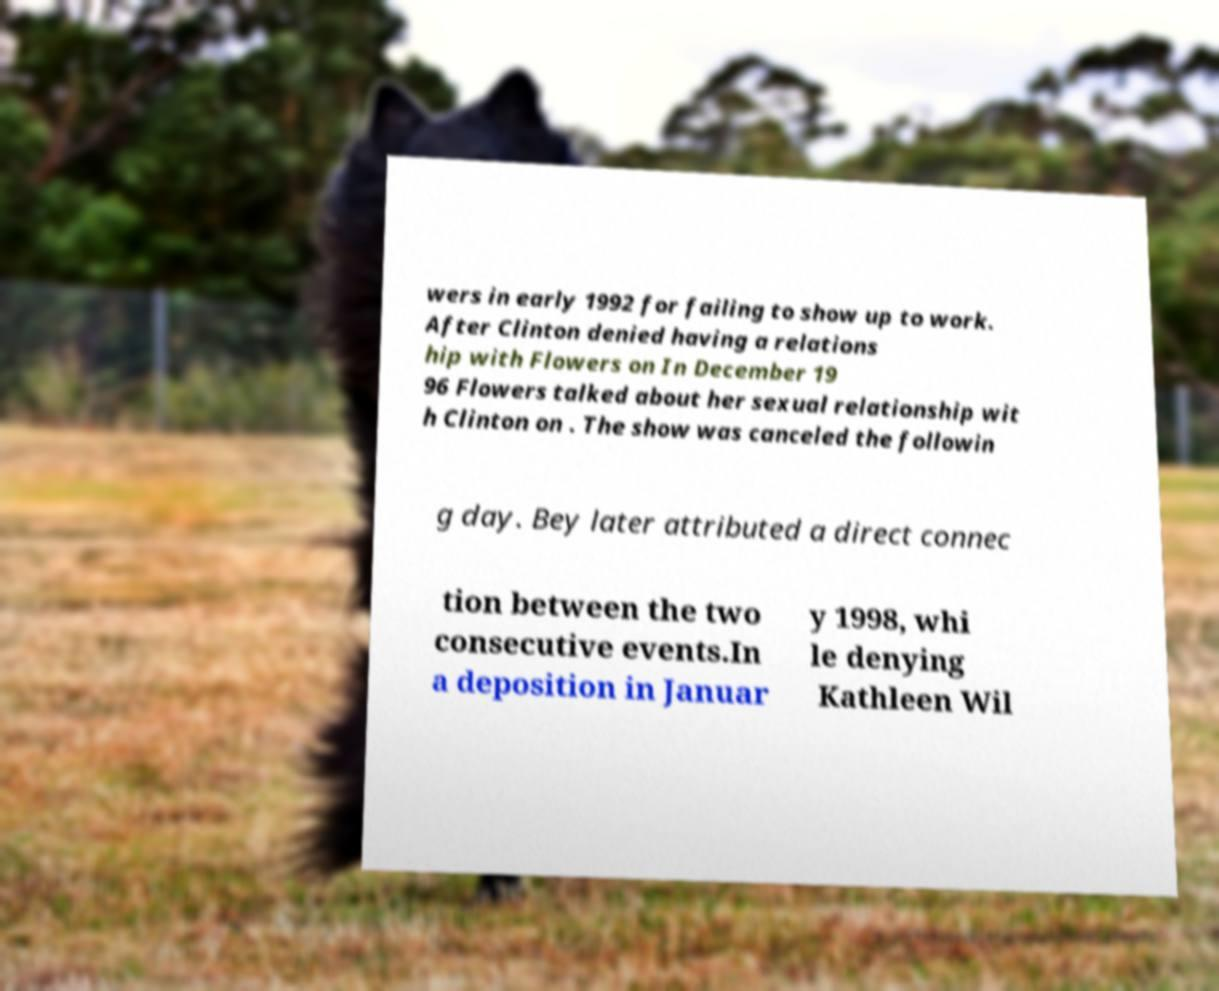For documentation purposes, I need the text within this image transcribed. Could you provide that? wers in early 1992 for failing to show up to work. After Clinton denied having a relations hip with Flowers on In December 19 96 Flowers talked about her sexual relationship wit h Clinton on . The show was canceled the followin g day. Bey later attributed a direct connec tion between the two consecutive events.In a deposition in Januar y 1998, whi le denying Kathleen Wil 